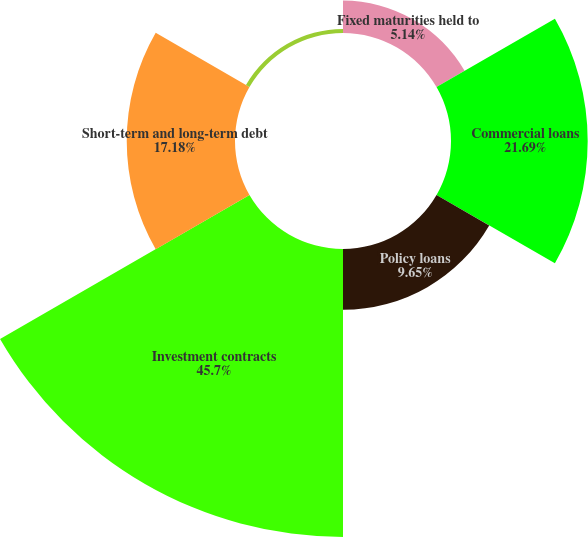Convert chart to OTSL. <chart><loc_0><loc_0><loc_500><loc_500><pie_chart><fcel>Fixed maturities held to<fcel>Commercial loans<fcel>Policy loans<fcel>Investment contracts<fcel>Short-term and long-term debt<fcel>Bank customer liabilities<nl><fcel>5.14%<fcel>21.69%<fcel>9.65%<fcel>45.7%<fcel>17.18%<fcel>0.64%<nl></chart> 